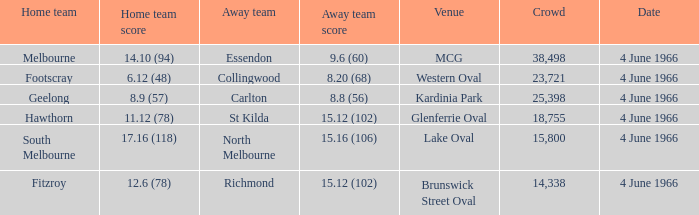What is the largest crowd size that watch a game where the home team scored 12.6 (78)? 14338.0. 